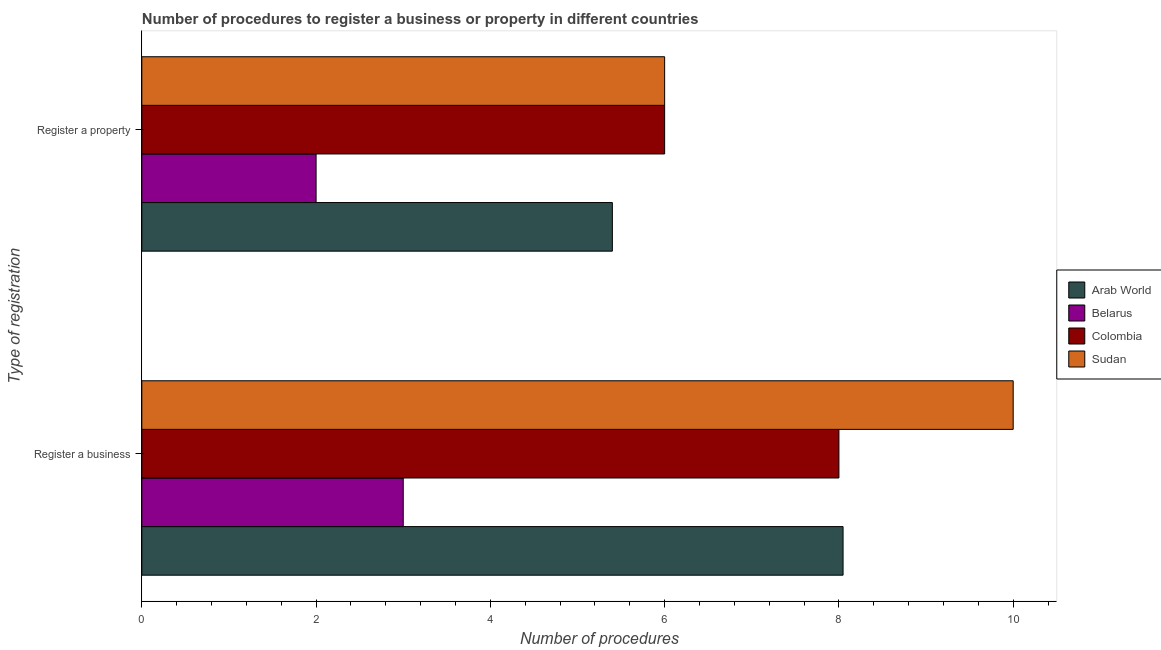How many different coloured bars are there?
Ensure brevity in your answer.  4. How many groups of bars are there?
Provide a short and direct response. 2. Are the number of bars on each tick of the Y-axis equal?
Offer a terse response. Yes. How many bars are there on the 2nd tick from the bottom?
Offer a very short reply. 4. What is the label of the 2nd group of bars from the top?
Your answer should be very brief. Register a business. In which country was the number of procedures to register a property maximum?
Your response must be concise. Colombia. In which country was the number of procedures to register a business minimum?
Give a very brief answer. Belarus. What is the total number of procedures to register a business in the graph?
Your answer should be compact. 29.05. What is the difference between the number of procedures to register a property in Colombia and the number of procedures to register a business in Belarus?
Offer a very short reply. 3. What is the average number of procedures to register a property per country?
Your answer should be very brief. 4.85. What is the difference between the number of procedures to register a business and number of procedures to register a property in Arab World?
Ensure brevity in your answer.  2.65. In how many countries, is the number of procedures to register a business greater than 6 ?
Ensure brevity in your answer.  3. What is the ratio of the number of procedures to register a property in Belarus to that in Sudan?
Your response must be concise. 0.33. Is the number of procedures to register a business in Belarus less than that in Arab World?
Your answer should be compact. Yes. In how many countries, is the number of procedures to register a business greater than the average number of procedures to register a business taken over all countries?
Make the answer very short. 3. What does the 1st bar from the top in Register a property represents?
Make the answer very short. Sudan. What does the 3rd bar from the bottom in Register a business represents?
Give a very brief answer. Colombia. How many bars are there?
Ensure brevity in your answer.  8. How many countries are there in the graph?
Your response must be concise. 4. Does the graph contain grids?
Your answer should be compact. No. How are the legend labels stacked?
Offer a terse response. Vertical. What is the title of the graph?
Keep it short and to the point. Number of procedures to register a business or property in different countries. What is the label or title of the X-axis?
Keep it short and to the point. Number of procedures. What is the label or title of the Y-axis?
Your response must be concise. Type of registration. What is the Number of procedures in Arab World in Register a business?
Your answer should be very brief. 8.05. What is the Number of procedures in Belarus in Register a property?
Make the answer very short. 2. Across all Type of registration, what is the maximum Number of procedures in Arab World?
Make the answer very short. 8.05. Across all Type of registration, what is the maximum Number of procedures of Belarus?
Keep it short and to the point. 3. Across all Type of registration, what is the maximum Number of procedures in Colombia?
Provide a succinct answer. 8. Across all Type of registration, what is the minimum Number of procedures in Belarus?
Provide a succinct answer. 2. Across all Type of registration, what is the minimum Number of procedures in Colombia?
Offer a very short reply. 6. Across all Type of registration, what is the minimum Number of procedures of Sudan?
Offer a very short reply. 6. What is the total Number of procedures in Arab World in the graph?
Keep it short and to the point. 13.45. What is the total Number of procedures in Sudan in the graph?
Offer a very short reply. 16. What is the difference between the Number of procedures of Arab World in Register a business and that in Register a property?
Provide a short and direct response. 2.65. What is the difference between the Number of procedures in Belarus in Register a business and that in Register a property?
Make the answer very short. 1. What is the difference between the Number of procedures in Colombia in Register a business and that in Register a property?
Make the answer very short. 2. What is the difference between the Number of procedures in Arab World in Register a business and the Number of procedures in Belarus in Register a property?
Give a very brief answer. 6.05. What is the difference between the Number of procedures of Arab World in Register a business and the Number of procedures of Colombia in Register a property?
Ensure brevity in your answer.  2.05. What is the difference between the Number of procedures in Arab World in Register a business and the Number of procedures in Sudan in Register a property?
Your answer should be compact. 2.05. What is the difference between the Number of procedures in Belarus in Register a business and the Number of procedures in Sudan in Register a property?
Your answer should be very brief. -3. What is the difference between the Number of procedures in Colombia in Register a business and the Number of procedures in Sudan in Register a property?
Your answer should be compact. 2. What is the average Number of procedures of Arab World per Type of registration?
Your response must be concise. 6.72. What is the average Number of procedures of Belarus per Type of registration?
Offer a terse response. 2.5. What is the average Number of procedures of Colombia per Type of registration?
Give a very brief answer. 7. What is the difference between the Number of procedures of Arab World and Number of procedures of Belarus in Register a business?
Make the answer very short. 5.05. What is the difference between the Number of procedures in Arab World and Number of procedures in Colombia in Register a business?
Make the answer very short. 0.05. What is the difference between the Number of procedures in Arab World and Number of procedures in Sudan in Register a business?
Ensure brevity in your answer.  -1.95. What is the difference between the Number of procedures in Belarus and Number of procedures in Colombia in Register a business?
Provide a short and direct response. -5. What is the difference between the Number of procedures in Belarus and Number of procedures in Sudan in Register a business?
Ensure brevity in your answer.  -7. What is the difference between the Number of procedures in Colombia and Number of procedures in Sudan in Register a business?
Make the answer very short. -2. What is the difference between the Number of procedures of Arab World and Number of procedures of Sudan in Register a property?
Give a very brief answer. -0.6. What is the difference between the Number of procedures of Belarus and Number of procedures of Colombia in Register a property?
Give a very brief answer. -4. What is the difference between the Number of procedures of Colombia and Number of procedures of Sudan in Register a property?
Your response must be concise. 0. What is the ratio of the Number of procedures in Arab World in Register a business to that in Register a property?
Provide a succinct answer. 1.49. What is the ratio of the Number of procedures in Colombia in Register a business to that in Register a property?
Offer a terse response. 1.33. What is the ratio of the Number of procedures of Sudan in Register a business to that in Register a property?
Provide a short and direct response. 1.67. What is the difference between the highest and the second highest Number of procedures in Arab World?
Provide a short and direct response. 2.65. What is the difference between the highest and the lowest Number of procedures in Arab World?
Ensure brevity in your answer.  2.65. What is the difference between the highest and the lowest Number of procedures in Sudan?
Your answer should be very brief. 4. 